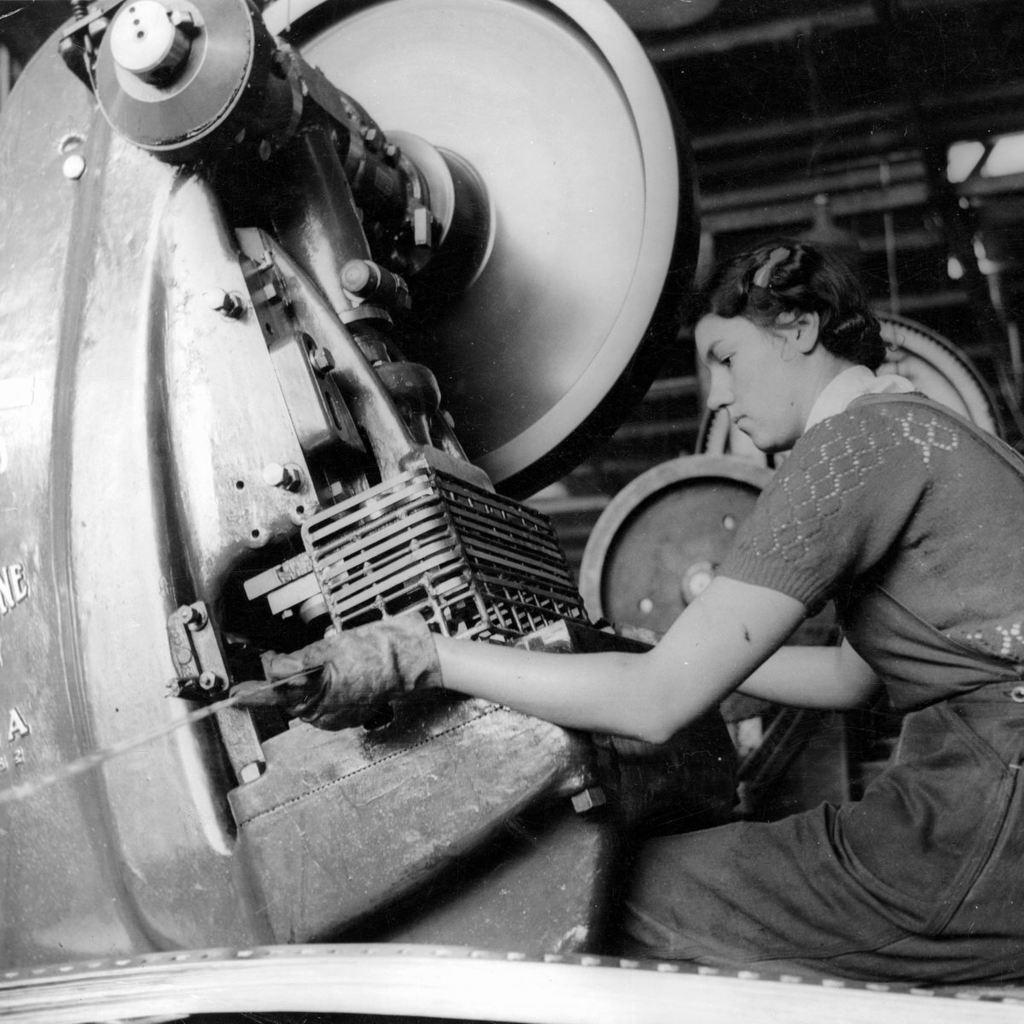How would you summarize this image in a sentence or two? In this image I can see the person sitting and I can also see the machine and the image is in black and white. 